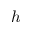Convert formula to latex. <formula><loc_0><loc_0><loc_500><loc_500>h</formula> 